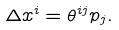Convert formula to latex. <formula><loc_0><loc_0><loc_500><loc_500>\Delta x ^ { i } = \theta ^ { i j } p _ { j } .</formula> 